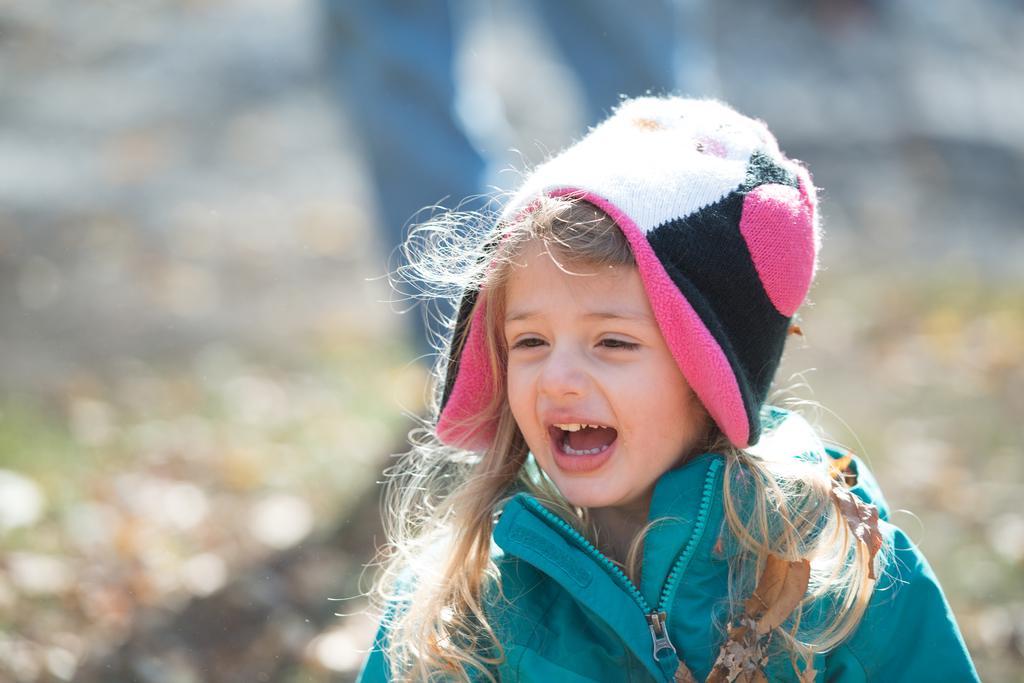How would you summarize this image in a sentence or two? In this picture there is a girl, wearing a blue jacket, she is smiling. The background is blurred. 